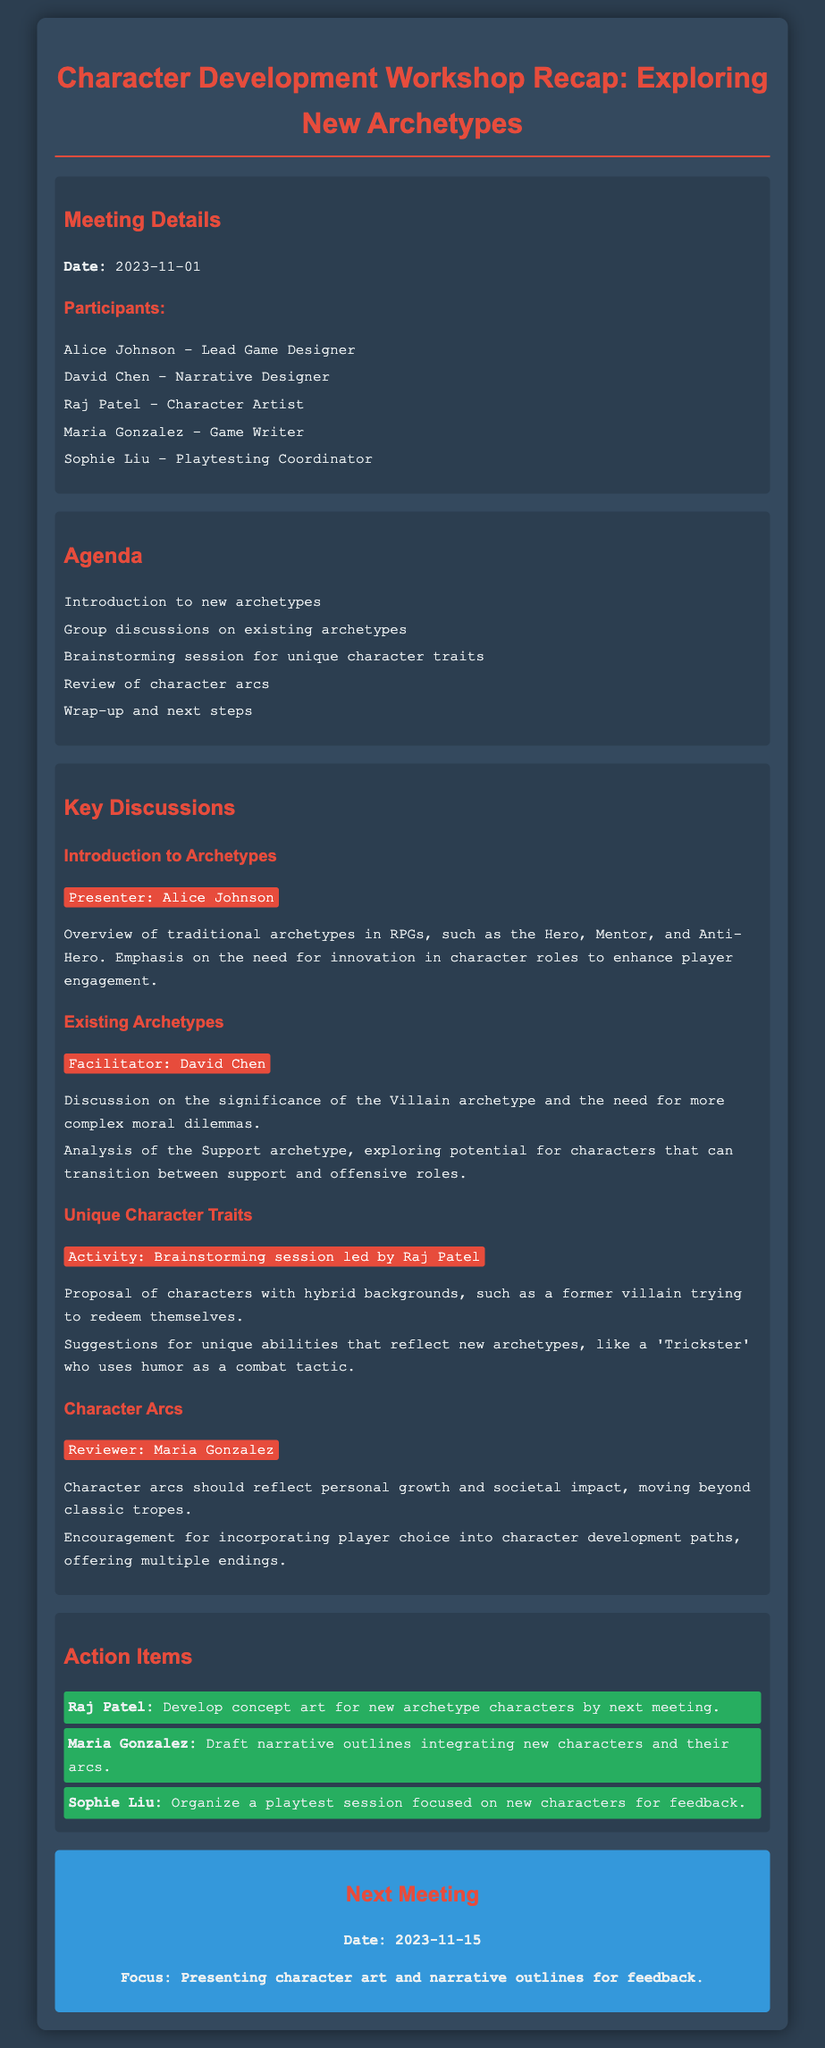What is the date of the workshop? The date of the workshop is provided in the meeting details section of the document.
Answer: 2023-11-01 Who presented the introduction to archetypes? The presenter of the introduction to archetypes is mentioned in the key discussions section of the document.
Answer: Alice Johnson What is one unique character trait proposed during the brainstorming session? The unique character traits proposed are listed under the unique character traits section, highlighting creativity in character development.
Answer: Former villain trying to redeem themselves Which archetype needs more complex moral dilemmas according to the discussion? The document discusses the significance of the villain archetype, specifically calling for complexity in its portrayal.
Answer: Villain What action item was assigned to Sophie Liu? The action items section clearly lists responsibilities assigned to each participant, including Sophie Liu.
Answer: Organize a playtest session focused on new characters for feedback What is the focus of the next meeting? The document provides details about the next meeting, indicating its purpose in the context of the ongoing character development work.
Answer: Presenting character art and narrative outlines for feedback 